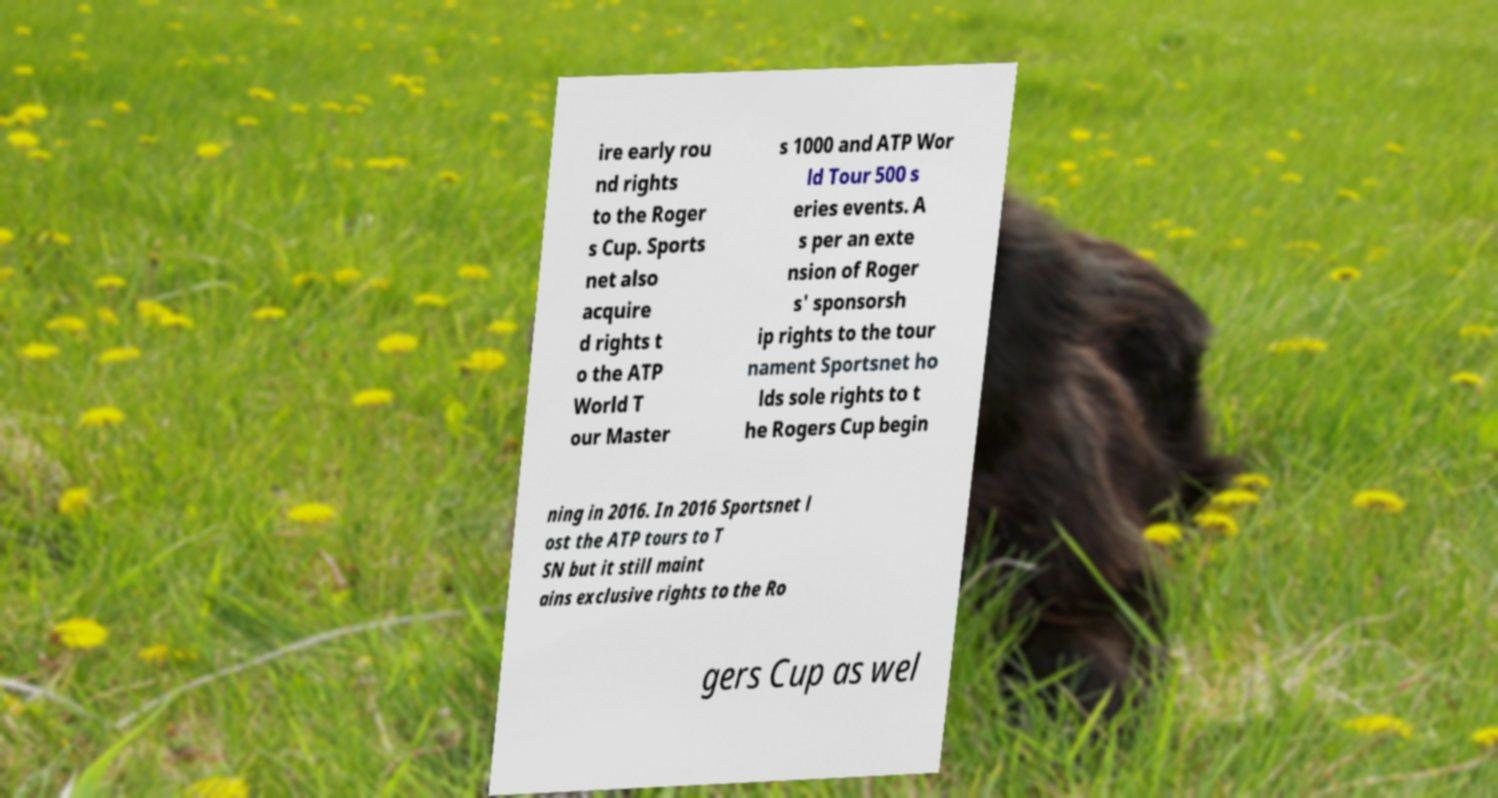Could you assist in decoding the text presented in this image and type it out clearly? ire early rou nd rights to the Roger s Cup. Sports net also acquire d rights t o the ATP World T our Master s 1000 and ATP Wor ld Tour 500 s eries events. A s per an exte nsion of Roger s' sponsorsh ip rights to the tour nament Sportsnet ho lds sole rights to t he Rogers Cup begin ning in 2016. In 2016 Sportsnet l ost the ATP tours to T SN but it still maint ains exclusive rights to the Ro gers Cup as wel 